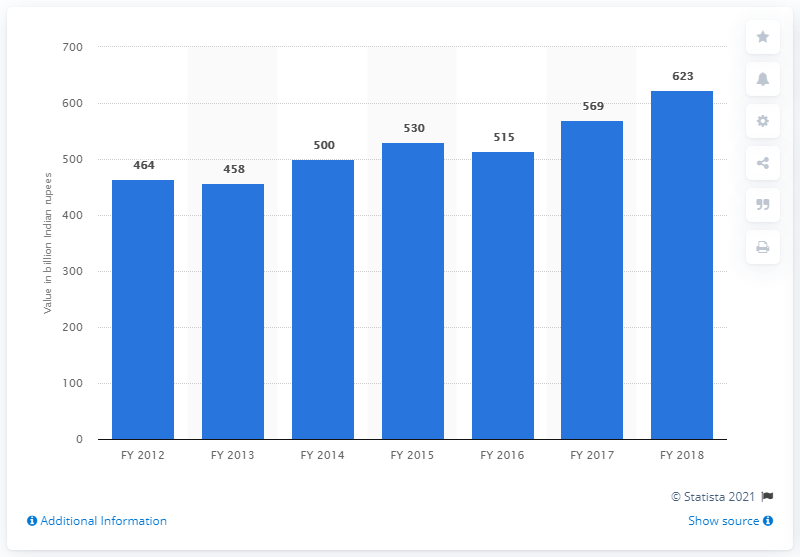List a handful of essential elements in this visual. In the fiscal year 2018, the Indian economy's condiments and spices sector accounted for 623 rupees. 